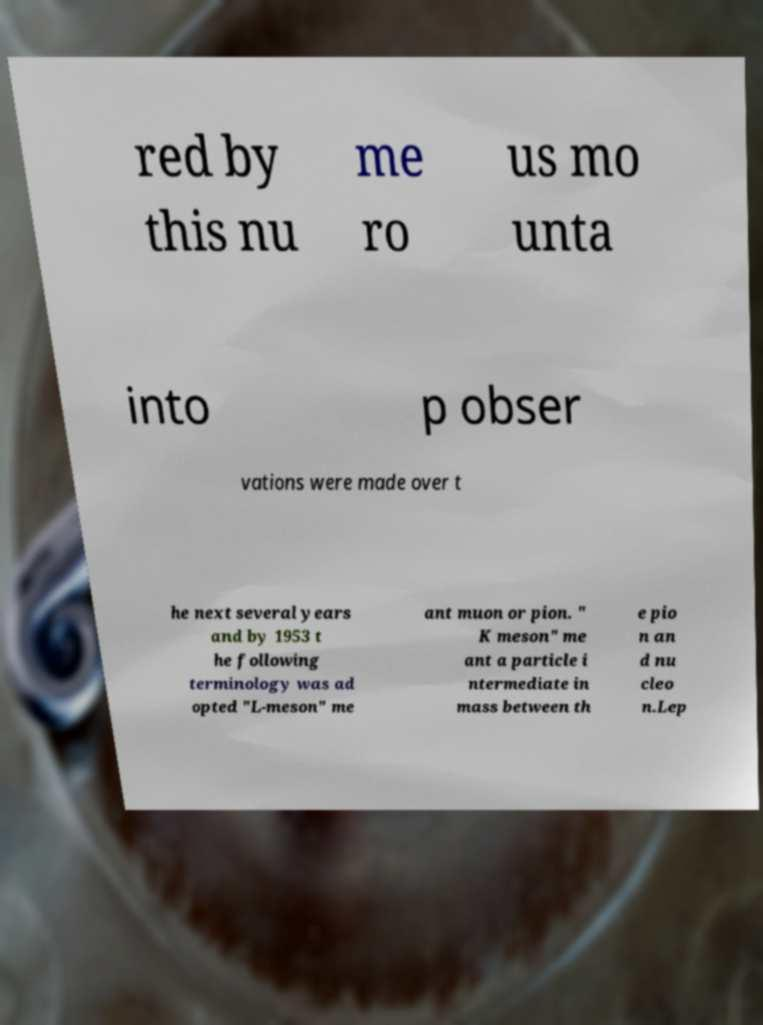Can you accurately transcribe the text from the provided image for me? red by this nu me ro us mo unta into p obser vations were made over t he next several years and by 1953 t he following terminology was ad opted "L-meson" me ant muon or pion. " K meson" me ant a particle i ntermediate in mass between th e pio n an d nu cleo n.Lep 